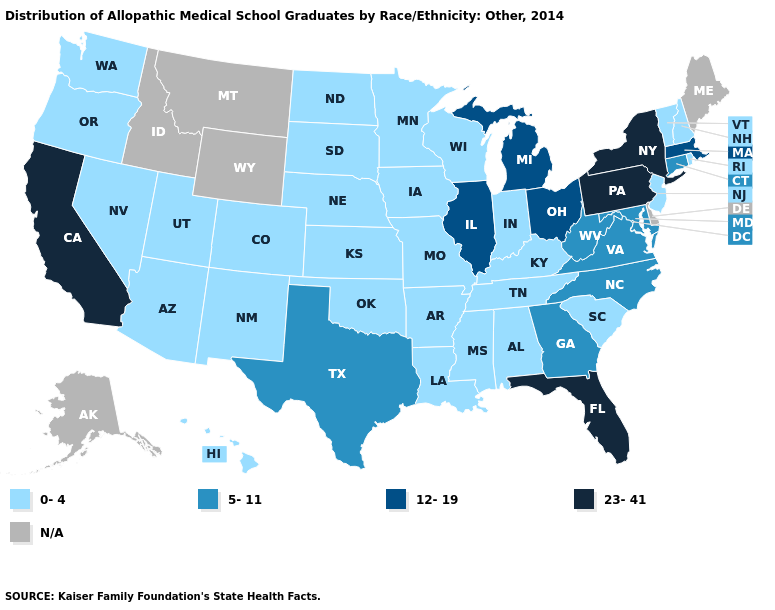Among the states that border South Dakota , which have the lowest value?
Keep it brief. Iowa, Minnesota, Nebraska, North Dakota. What is the lowest value in the USA?
Give a very brief answer. 0-4. What is the value of California?
Give a very brief answer. 23-41. What is the value of Montana?
Quick response, please. N/A. What is the highest value in the USA?
Answer briefly. 23-41. What is the lowest value in states that border Minnesota?
Concise answer only. 0-4. Does Maryland have the lowest value in the South?
Answer briefly. No. Does Colorado have the highest value in the West?
Be succinct. No. What is the value of Delaware?
Short answer required. N/A. Which states hav the highest value in the South?
Short answer required. Florida. What is the lowest value in states that border Minnesota?
Answer briefly. 0-4. What is the value of Idaho?
Be succinct. N/A. Among the states that border Massachusetts , which have the lowest value?
Be succinct. New Hampshire, Rhode Island, Vermont. Which states have the lowest value in the USA?
Keep it brief. Alabama, Arizona, Arkansas, Colorado, Hawaii, Indiana, Iowa, Kansas, Kentucky, Louisiana, Minnesota, Mississippi, Missouri, Nebraska, Nevada, New Hampshire, New Jersey, New Mexico, North Dakota, Oklahoma, Oregon, Rhode Island, South Carolina, South Dakota, Tennessee, Utah, Vermont, Washington, Wisconsin. What is the highest value in the Northeast ?
Short answer required. 23-41. 